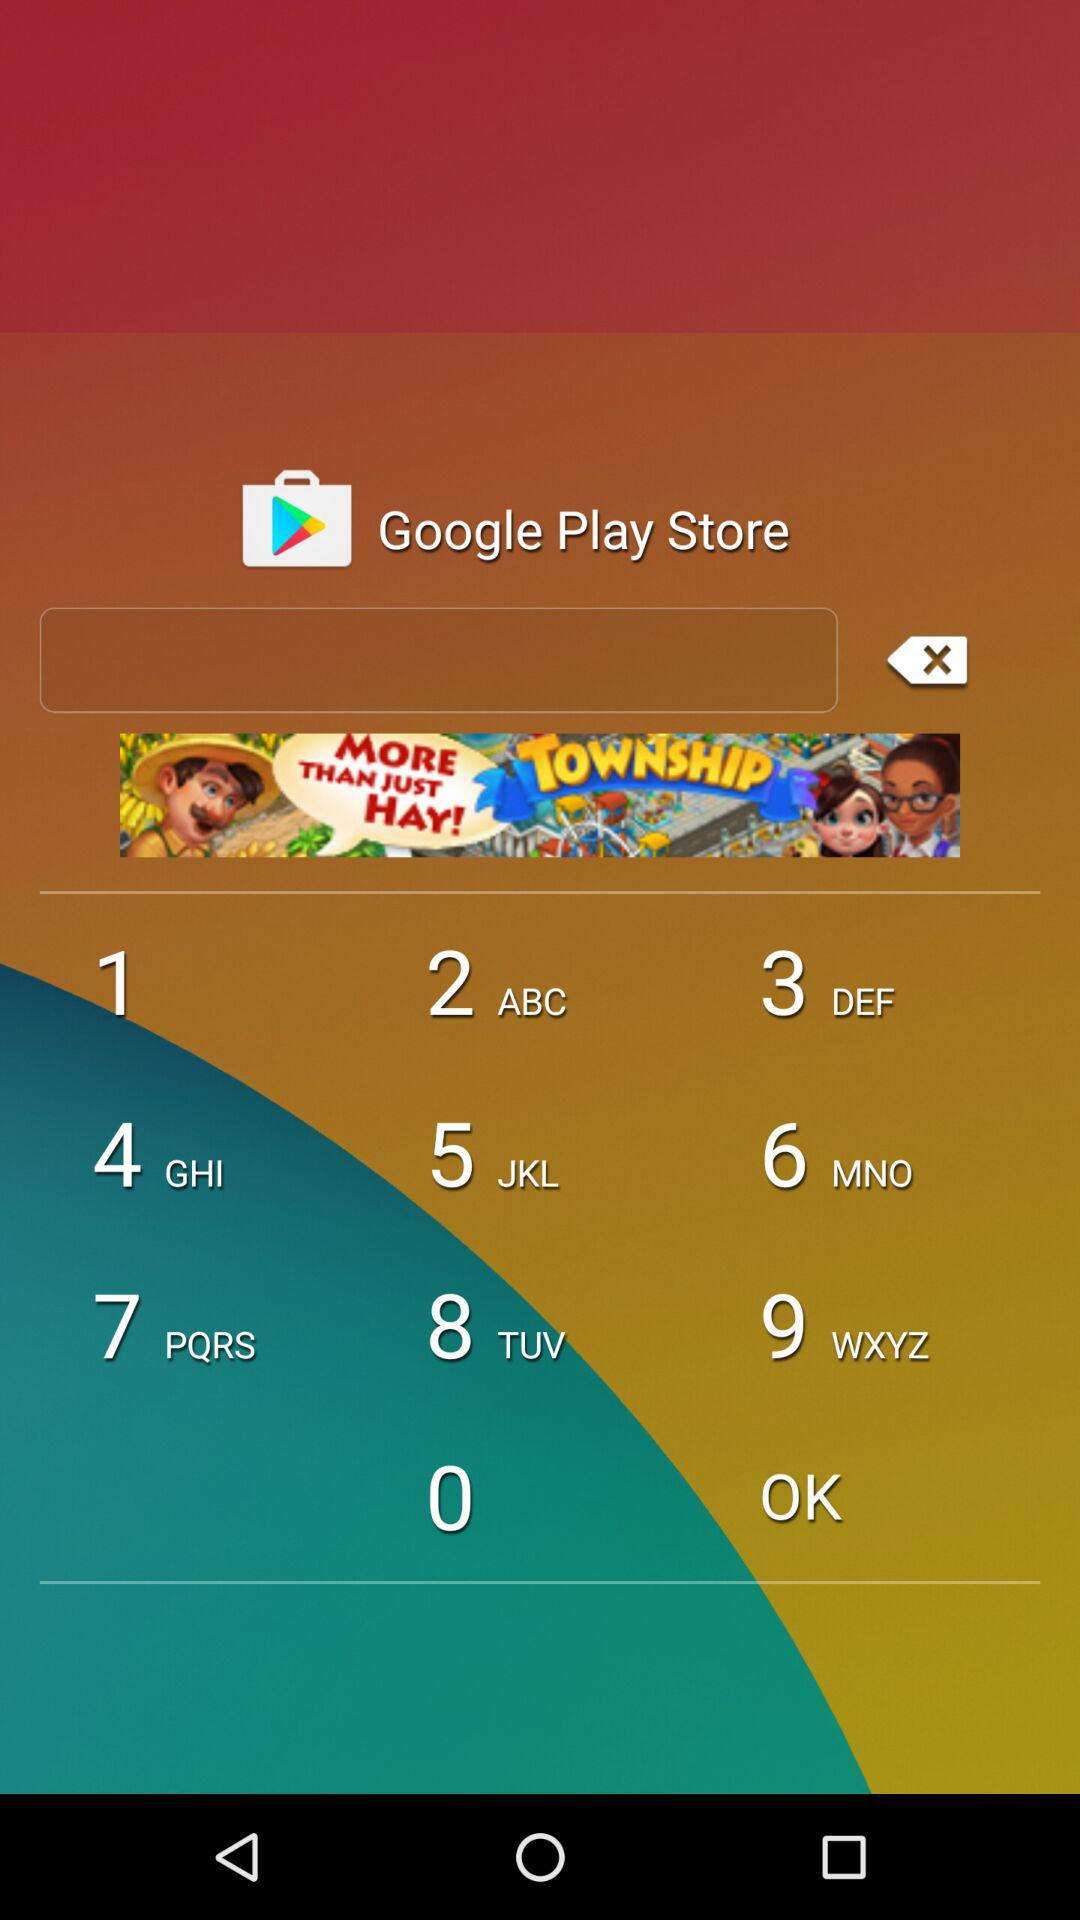What is the code? The code is "vj7imu". 